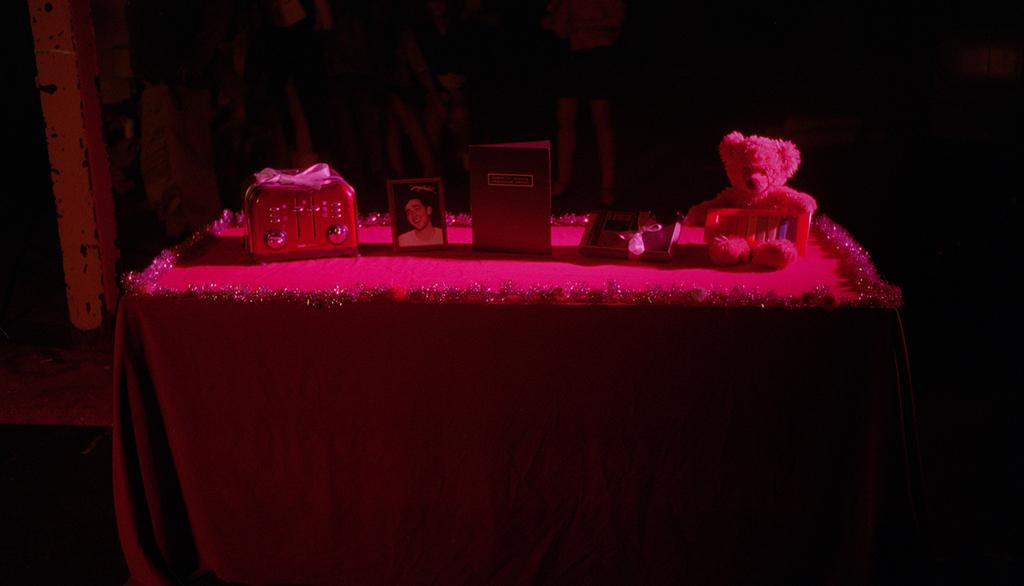What is placed on the table in the image? There is a teddy, a book, and a picture on the table. Can you describe any other items on the table? There are unspecified "things" on the table. What type of skirt is the teddy wearing in the image? The teddy is a stuffed animal and does not wear clothing, so it is not wearing a skirt in the image. 